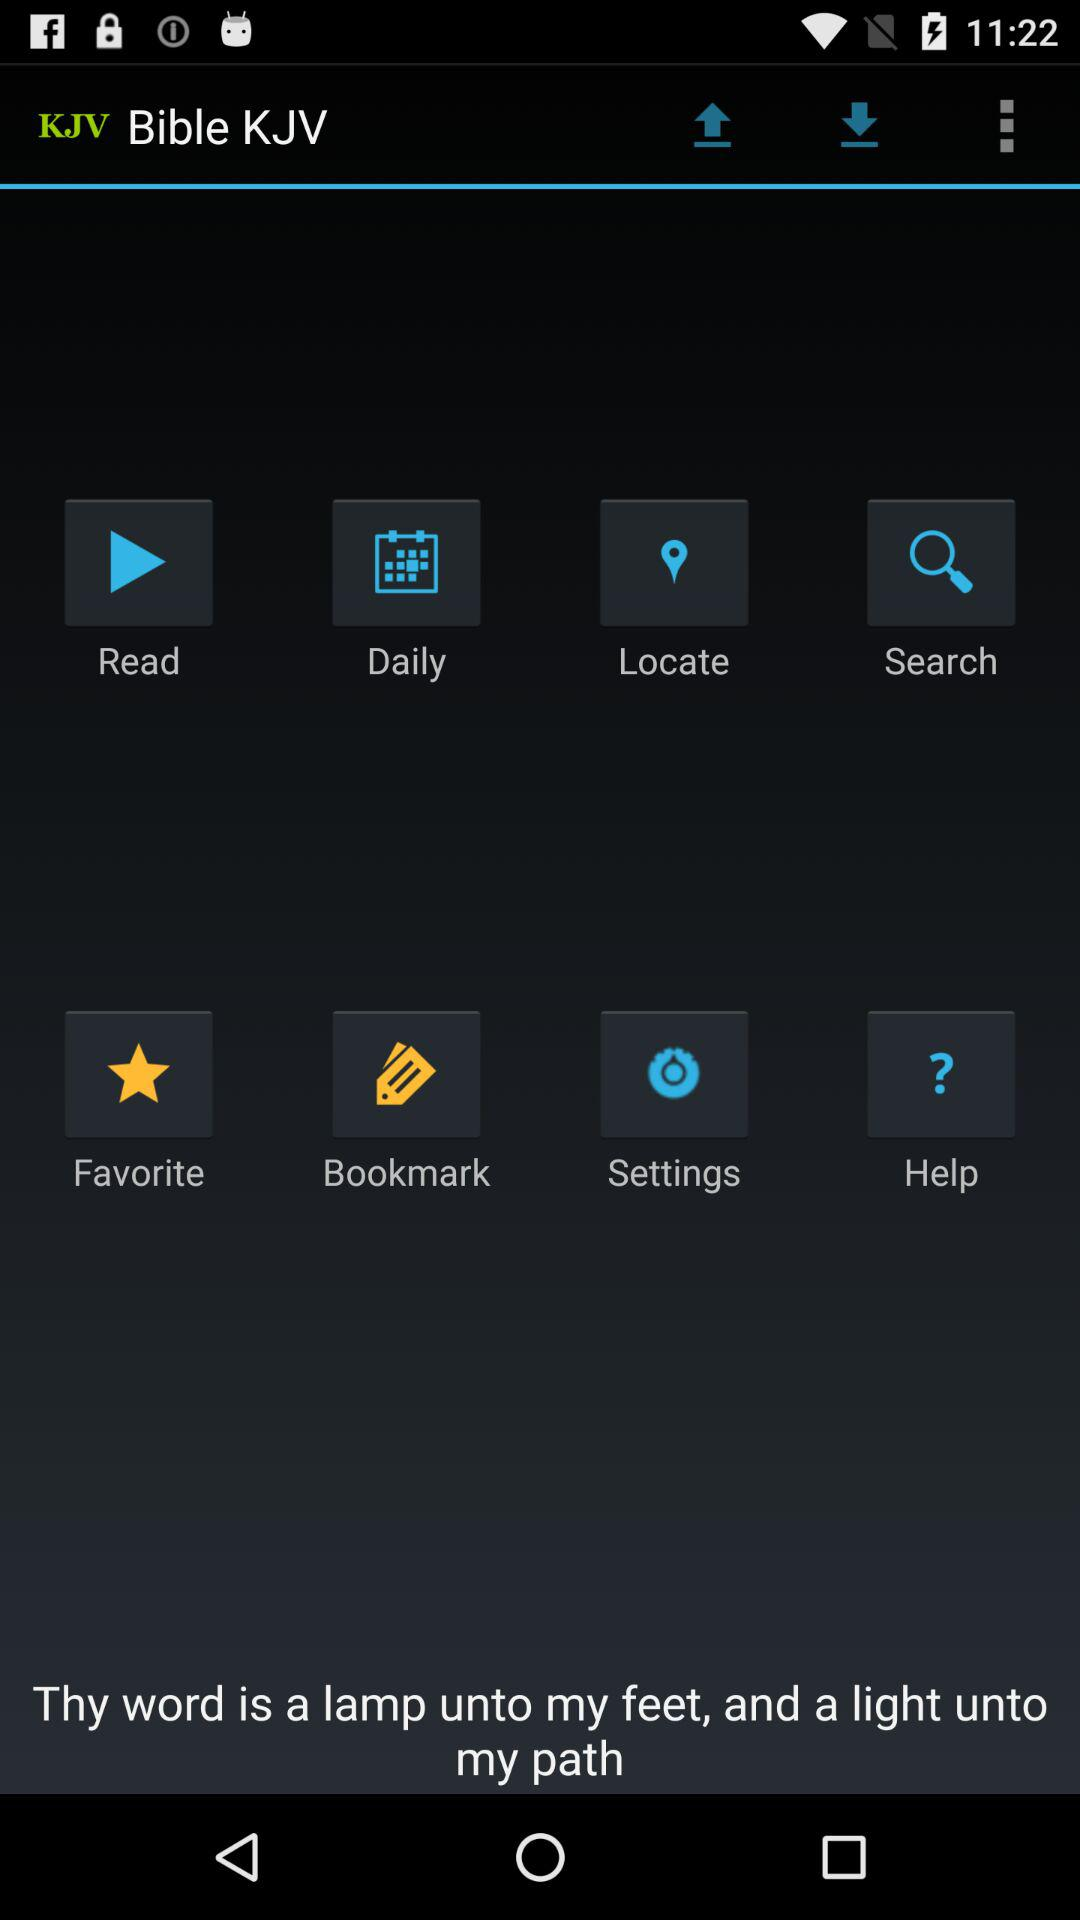What is the name of the application? The name of the application is "Bible KJV". 